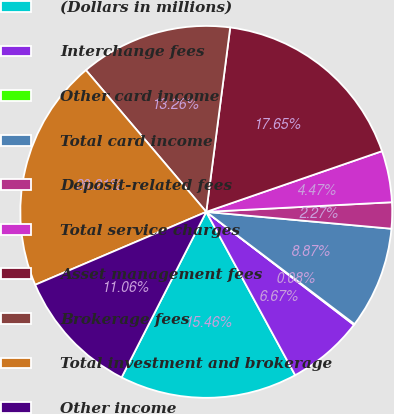Convert chart. <chart><loc_0><loc_0><loc_500><loc_500><pie_chart><fcel>(Dollars in millions)<fcel>Interchange fees<fcel>Other card income<fcel>Total card income<fcel>Deposit-related fees<fcel>Total service charges<fcel>Asset management fees<fcel>Brokerage fees<fcel>Total investment and brokerage<fcel>Other income<nl><fcel>15.46%<fcel>6.67%<fcel>0.08%<fcel>8.87%<fcel>2.27%<fcel>4.47%<fcel>17.65%<fcel>13.26%<fcel>20.21%<fcel>11.06%<nl></chart> 